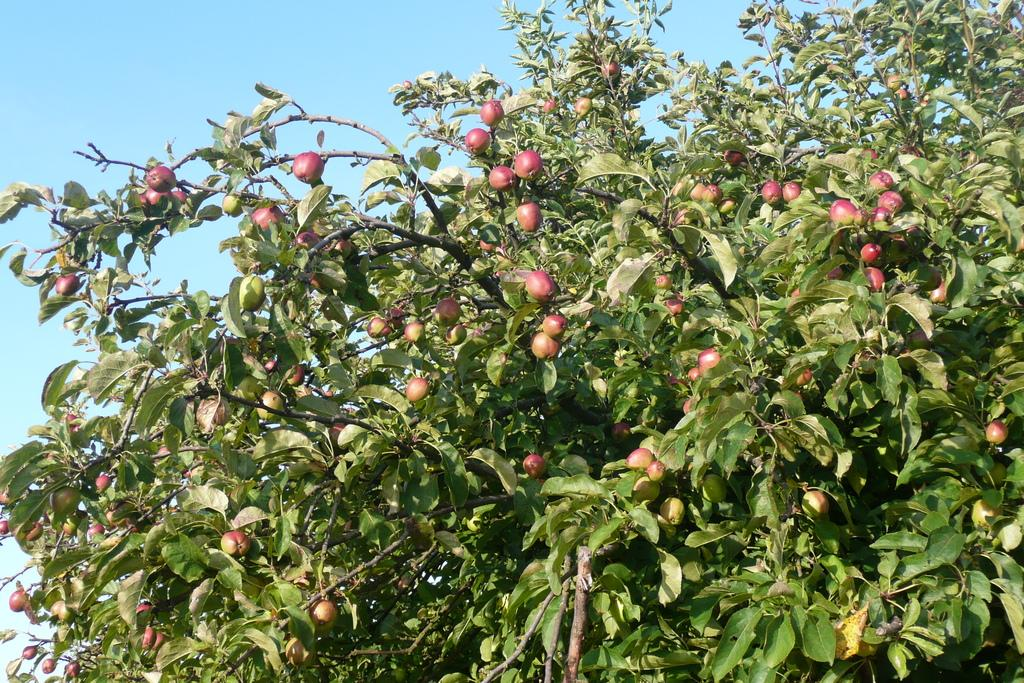What is the main object in the image? There is a tree in the image. What is special about the tree? The tree has many fruits. What can be seen in the background of the image? The sky is visible at the top of the image. What type of respect is being shown in the image? There is no indication of respect being shown in the image, as it only features a tree with many fruits and the sky in the background. 